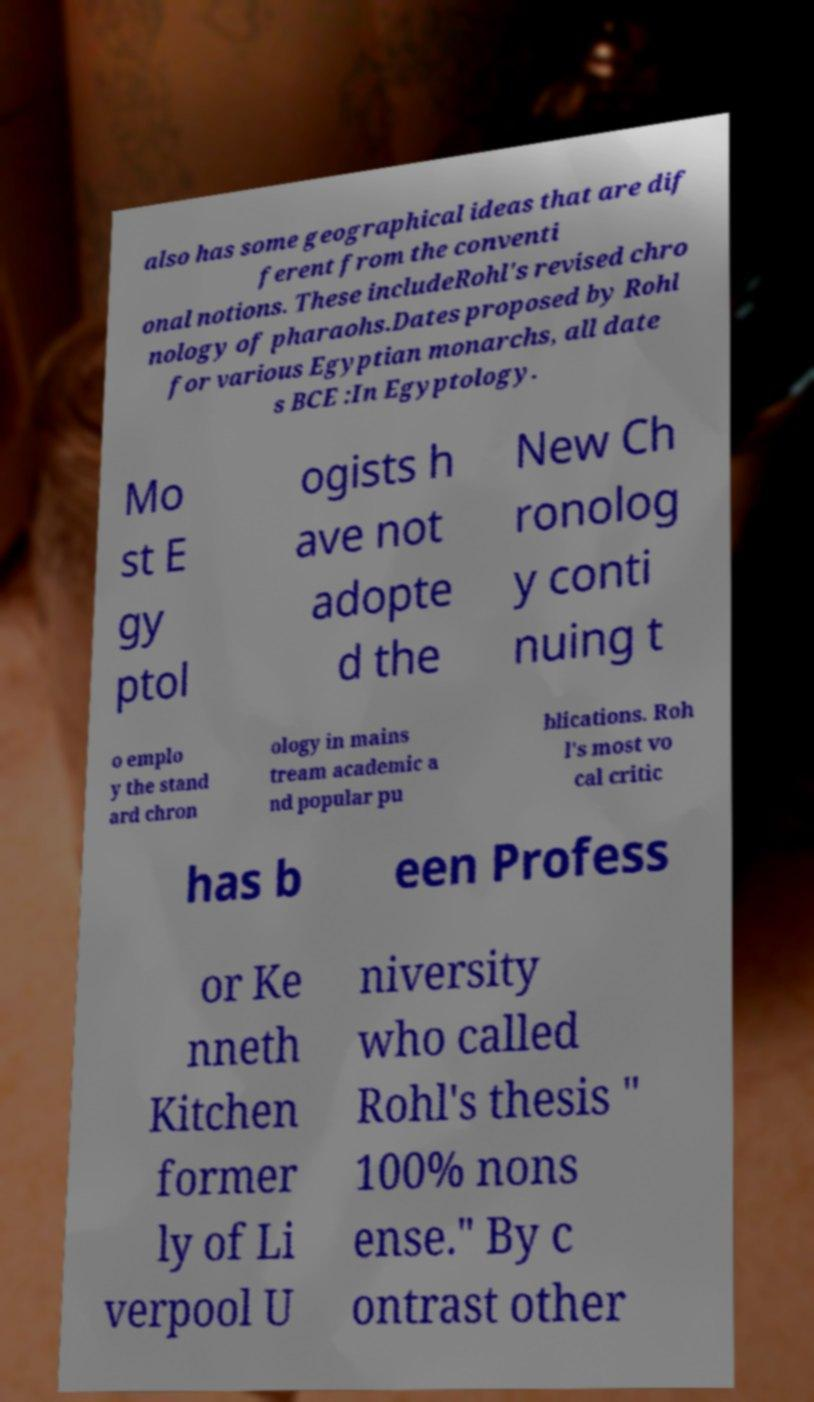There's text embedded in this image that I need extracted. Can you transcribe it verbatim? also has some geographical ideas that are dif ferent from the conventi onal notions. These includeRohl's revised chro nology of pharaohs.Dates proposed by Rohl for various Egyptian monarchs, all date s BCE :In Egyptology. Mo st E gy ptol ogists h ave not adopte d the New Ch ronolog y conti nuing t o emplo y the stand ard chron ology in mains tream academic a nd popular pu blications. Roh l's most vo cal critic has b een Profess or Ke nneth Kitchen former ly of Li verpool U niversity who called Rohl's thesis " 100% nons ense." By c ontrast other 